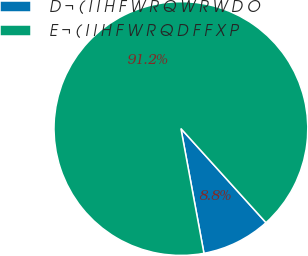Convert chart. <chart><loc_0><loc_0><loc_500><loc_500><pie_chart><fcel>D ¬ ( I I H F W R Q W R W D O<fcel>E ¬ ( I I H F W R Q D F F X P<nl><fcel>8.79%<fcel>91.21%<nl></chart> 